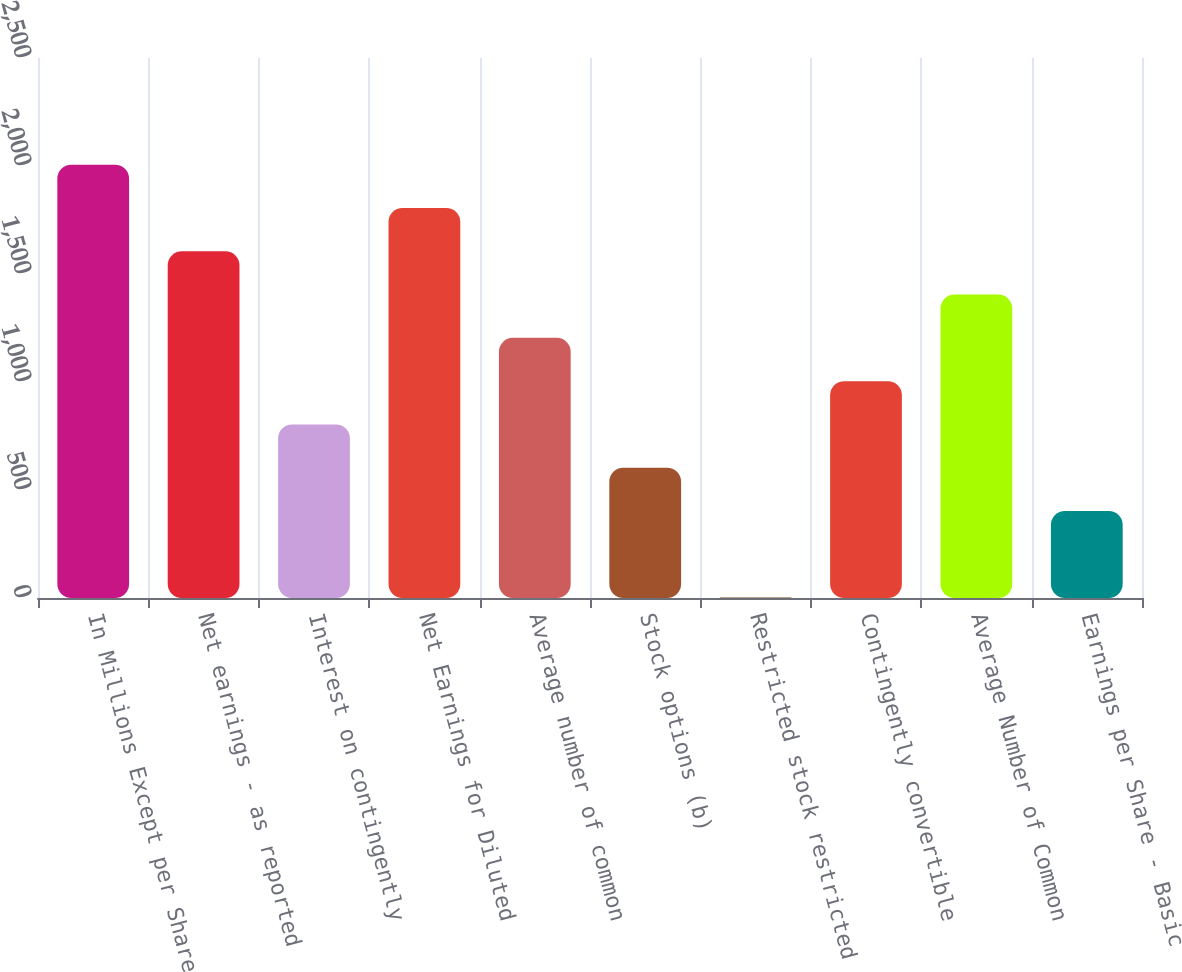Convert chart to OTSL. <chart><loc_0><loc_0><loc_500><loc_500><bar_chart><fcel>In Millions Except per Share<fcel>Net earnings - as reported<fcel>Interest on contingently<fcel>Net Earnings for Diluted<fcel>Average number of common<fcel>Stock options (b)<fcel>Restricted stock restricted<fcel>Contingently convertible<fcel>Average Number of Common<fcel>Earnings per Share - Basic<nl><fcel>2006<fcel>1605.2<fcel>803.6<fcel>1805.6<fcel>1204.4<fcel>603.2<fcel>2<fcel>1004<fcel>1404.8<fcel>402.8<nl></chart> 